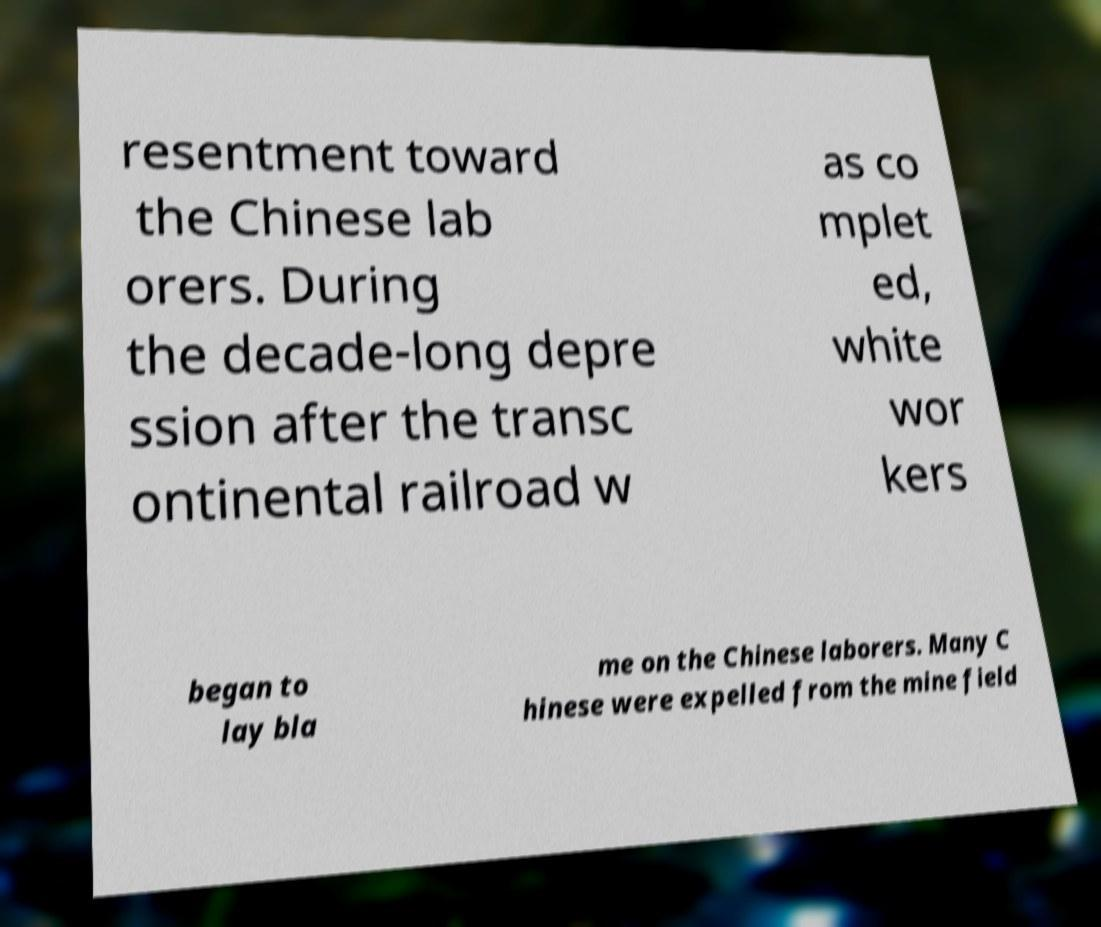Can you read and provide the text displayed in the image?This photo seems to have some interesting text. Can you extract and type it out for me? resentment toward the Chinese lab orers. During the decade-long depre ssion after the transc ontinental railroad w as co mplet ed, white wor kers began to lay bla me on the Chinese laborers. Many C hinese were expelled from the mine field 